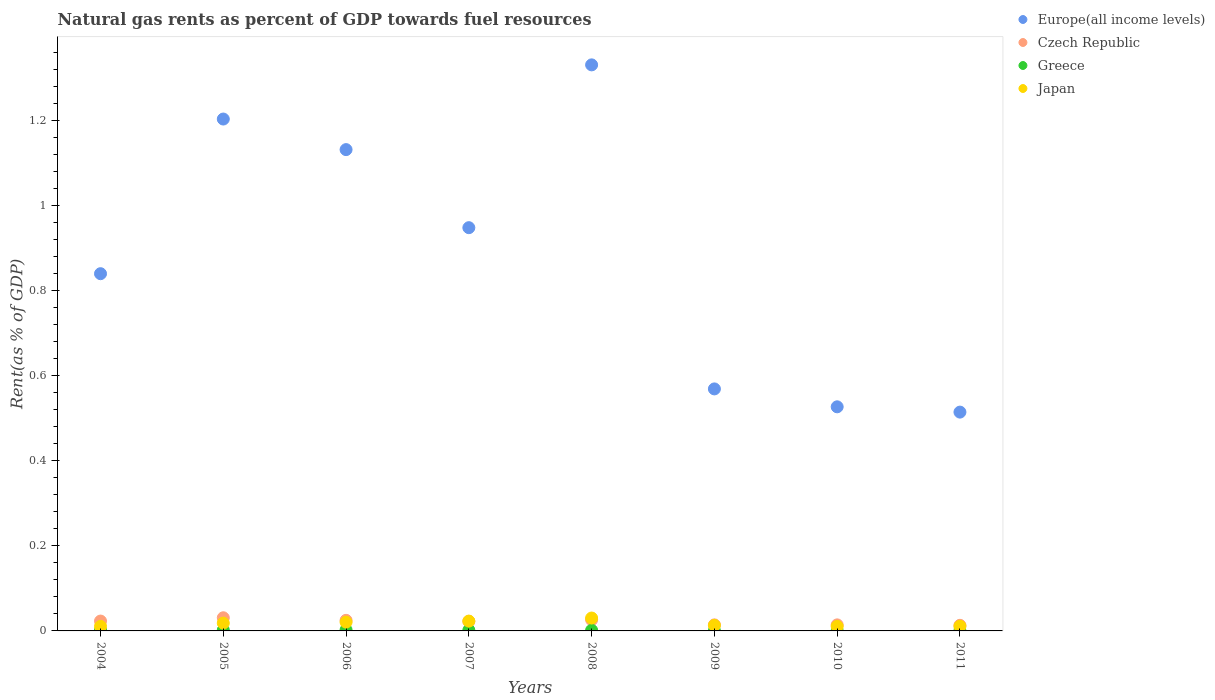Is the number of dotlines equal to the number of legend labels?
Provide a short and direct response. Yes. What is the matural gas rent in Japan in 2011?
Offer a terse response. 0.01. Across all years, what is the maximum matural gas rent in Europe(all income levels)?
Provide a succinct answer. 1.33. Across all years, what is the minimum matural gas rent in Greece?
Your answer should be very brief. 0. In which year was the matural gas rent in Japan minimum?
Your answer should be compact. 2010. What is the total matural gas rent in Greece in the graph?
Provide a short and direct response. 0.01. What is the difference between the matural gas rent in Europe(all income levels) in 2004 and that in 2006?
Your answer should be compact. -0.29. What is the difference between the matural gas rent in Europe(all income levels) in 2006 and the matural gas rent in Japan in 2011?
Ensure brevity in your answer.  1.12. What is the average matural gas rent in Japan per year?
Your answer should be compact. 0.02. In the year 2006, what is the difference between the matural gas rent in Greece and matural gas rent in Europe(all income levels)?
Ensure brevity in your answer.  -1.13. In how many years, is the matural gas rent in Czech Republic greater than 0.28 %?
Offer a very short reply. 0. What is the ratio of the matural gas rent in Greece in 2005 to that in 2009?
Make the answer very short. 3.53. What is the difference between the highest and the second highest matural gas rent in Japan?
Your answer should be compact. 0.01. What is the difference between the highest and the lowest matural gas rent in Japan?
Your answer should be compact. 0.02. In how many years, is the matural gas rent in Europe(all income levels) greater than the average matural gas rent in Europe(all income levels) taken over all years?
Offer a very short reply. 4. Is it the case that in every year, the sum of the matural gas rent in Japan and matural gas rent in Czech Republic  is greater than the sum of matural gas rent in Europe(all income levels) and matural gas rent in Greece?
Give a very brief answer. No. Is it the case that in every year, the sum of the matural gas rent in Europe(all income levels) and matural gas rent in Czech Republic  is greater than the matural gas rent in Japan?
Make the answer very short. Yes. Is the matural gas rent in Czech Republic strictly greater than the matural gas rent in Japan over the years?
Ensure brevity in your answer.  No. How many years are there in the graph?
Offer a terse response. 8. What is the difference between two consecutive major ticks on the Y-axis?
Your answer should be very brief. 0.2. Are the values on the major ticks of Y-axis written in scientific E-notation?
Your answer should be very brief. No. Does the graph contain any zero values?
Your answer should be very brief. No. Does the graph contain grids?
Ensure brevity in your answer.  No. How are the legend labels stacked?
Provide a succinct answer. Vertical. What is the title of the graph?
Ensure brevity in your answer.  Natural gas rents as percent of GDP towards fuel resources. Does "Mozambique" appear as one of the legend labels in the graph?
Offer a very short reply. No. What is the label or title of the Y-axis?
Keep it short and to the point. Rent(as % of GDP). What is the Rent(as % of GDP) of Europe(all income levels) in 2004?
Give a very brief answer. 0.84. What is the Rent(as % of GDP) in Czech Republic in 2004?
Your answer should be very brief. 0.02. What is the Rent(as % of GDP) of Greece in 2004?
Make the answer very short. 0. What is the Rent(as % of GDP) in Japan in 2004?
Keep it short and to the point. 0.01. What is the Rent(as % of GDP) of Europe(all income levels) in 2005?
Offer a terse response. 1.2. What is the Rent(as % of GDP) of Czech Republic in 2005?
Keep it short and to the point. 0.03. What is the Rent(as % of GDP) of Greece in 2005?
Your answer should be compact. 0. What is the Rent(as % of GDP) in Japan in 2005?
Your answer should be compact. 0.02. What is the Rent(as % of GDP) in Europe(all income levels) in 2006?
Make the answer very short. 1.13. What is the Rent(as % of GDP) of Czech Republic in 2006?
Provide a succinct answer. 0.02. What is the Rent(as % of GDP) in Greece in 2006?
Offer a terse response. 0. What is the Rent(as % of GDP) of Japan in 2006?
Provide a short and direct response. 0.02. What is the Rent(as % of GDP) of Europe(all income levels) in 2007?
Ensure brevity in your answer.  0.95. What is the Rent(as % of GDP) of Czech Republic in 2007?
Provide a succinct answer. 0.02. What is the Rent(as % of GDP) in Greece in 2007?
Your answer should be compact. 0. What is the Rent(as % of GDP) in Japan in 2007?
Offer a very short reply. 0.02. What is the Rent(as % of GDP) of Europe(all income levels) in 2008?
Ensure brevity in your answer.  1.33. What is the Rent(as % of GDP) of Czech Republic in 2008?
Make the answer very short. 0.03. What is the Rent(as % of GDP) of Greece in 2008?
Provide a short and direct response. 0. What is the Rent(as % of GDP) in Japan in 2008?
Keep it short and to the point. 0.03. What is the Rent(as % of GDP) in Europe(all income levels) in 2009?
Offer a very short reply. 0.57. What is the Rent(as % of GDP) in Czech Republic in 2009?
Provide a succinct answer. 0.01. What is the Rent(as % of GDP) of Greece in 2009?
Ensure brevity in your answer.  0. What is the Rent(as % of GDP) in Japan in 2009?
Make the answer very short. 0.01. What is the Rent(as % of GDP) of Europe(all income levels) in 2010?
Your answer should be compact. 0.53. What is the Rent(as % of GDP) in Czech Republic in 2010?
Give a very brief answer. 0.01. What is the Rent(as % of GDP) in Greece in 2010?
Provide a short and direct response. 0. What is the Rent(as % of GDP) in Japan in 2010?
Ensure brevity in your answer.  0.01. What is the Rent(as % of GDP) of Europe(all income levels) in 2011?
Your answer should be compact. 0.51. What is the Rent(as % of GDP) of Czech Republic in 2011?
Provide a succinct answer. 0.01. What is the Rent(as % of GDP) in Greece in 2011?
Provide a succinct answer. 0. What is the Rent(as % of GDP) of Japan in 2011?
Make the answer very short. 0.01. Across all years, what is the maximum Rent(as % of GDP) in Europe(all income levels)?
Make the answer very short. 1.33. Across all years, what is the maximum Rent(as % of GDP) in Czech Republic?
Offer a very short reply. 0.03. Across all years, what is the maximum Rent(as % of GDP) of Greece?
Provide a succinct answer. 0. Across all years, what is the maximum Rent(as % of GDP) of Japan?
Provide a short and direct response. 0.03. Across all years, what is the minimum Rent(as % of GDP) in Europe(all income levels)?
Your answer should be very brief. 0.51. Across all years, what is the minimum Rent(as % of GDP) of Czech Republic?
Keep it short and to the point. 0.01. Across all years, what is the minimum Rent(as % of GDP) in Greece?
Your response must be concise. 0. Across all years, what is the minimum Rent(as % of GDP) in Japan?
Provide a succinct answer. 0.01. What is the total Rent(as % of GDP) in Europe(all income levels) in the graph?
Give a very brief answer. 7.06. What is the total Rent(as % of GDP) in Czech Republic in the graph?
Provide a succinct answer. 0.17. What is the total Rent(as % of GDP) of Greece in the graph?
Ensure brevity in your answer.  0.01. What is the total Rent(as % of GDP) in Japan in the graph?
Provide a succinct answer. 0.14. What is the difference between the Rent(as % of GDP) in Europe(all income levels) in 2004 and that in 2005?
Ensure brevity in your answer.  -0.36. What is the difference between the Rent(as % of GDP) in Czech Republic in 2004 and that in 2005?
Offer a terse response. -0.01. What is the difference between the Rent(as % of GDP) in Greece in 2004 and that in 2005?
Your response must be concise. 0. What is the difference between the Rent(as % of GDP) of Japan in 2004 and that in 2005?
Offer a terse response. -0.01. What is the difference between the Rent(as % of GDP) of Europe(all income levels) in 2004 and that in 2006?
Provide a succinct answer. -0.29. What is the difference between the Rent(as % of GDP) of Czech Republic in 2004 and that in 2006?
Offer a terse response. -0. What is the difference between the Rent(as % of GDP) in Greece in 2004 and that in 2006?
Your answer should be very brief. -0. What is the difference between the Rent(as % of GDP) in Japan in 2004 and that in 2006?
Give a very brief answer. -0.01. What is the difference between the Rent(as % of GDP) of Europe(all income levels) in 2004 and that in 2007?
Your answer should be compact. -0.11. What is the difference between the Rent(as % of GDP) of Czech Republic in 2004 and that in 2007?
Give a very brief answer. 0. What is the difference between the Rent(as % of GDP) of Japan in 2004 and that in 2007?
Provide a short and direct response. -0.01. What is the difference between the Rent(as % of GDP) of Europe(all income levels) in 2004 and that in 2008?
Give a very brief answer. -0.49. What is the difference between the Rent(as % of GDP) in Czech Republic in 2004 and that in 2008?
Provide a succinct answer. -0. What is the difference between the Rent(as % of GDP) in Greece in 2004 and that in 2008?
Give a very brief answer. 0. What is the difference between the Rent(as % of GDP) in Japan in 2004 and that in 2008?
Give a very brief answer. -0.02. What is the difference between the Rent(as % of GDP) of Europe(all income levels) in 2004 and that in 2009?
Offer a terse response. 0.27. What is the difference between the Rent(as % of GDP) in Czech Republic in 2004 and that in 2009?
Your response must be concise. 0.01. What is the difference between the Rent(as % of GDP) of Greece in 2004 and that in 2009?
Provide a succinct answer. 0. What is the difference between the Rent(as % of GDP) of Japan in 2004 and that in 2009?
Ensure brevity in your answer.  -0. What is the difference between the Rent(as % of GDP) in Europe(all income levels) in 2004 and that in 2010?
Make the answer very short. 0.31. What is the difference between the Rent(as % of GDP) of Czech Republic in 2004 and that in 2010?
Ensure brevity in your answer.  0.01. What is the difference between the Rent(as % of GDP) in Greece in 2004 and that in 2010?
Offer a terse response. 0. What is the difference between the Rent(as % of GDP) of Japan in 2004 and that in 2010?
Provide a succinct answer. 0. What is the difference between the Rent(as % of GDP) in Europe(all income levels) in 2004 and that in 2011?
Ensure brevity in your answer.  0.33. What is the difference between the Rent(as % of GDP) of Czech Republic in 2004 and that in 2011?
Your response must be concise. 0.01. What is the difference between the Rent(as % of GDP) in Greece in 2004 and that in 2011?
Give a very brief answer. 0. What is the difference between the Rent(as % of GDP) of Japan in 2004 and that in 2011?
Make the answer very short. -0. What is the difference between the Rent(as % of GDP) of Europe(all income levels) in 2005 and that in 2006?
Your response must be concise. 0.07. What is the difference between the Rent(as % of GDP) of Czech Republic in 2005 and that in 2006?
Keep it short and to the point. 0.01. What is the difference between the Rent(as % of GDP) in Greece in 2005 and that in 2006?
Keep it short and to the point. -0. What is the difference between the Rent(as % of GDP) in Japan in 2005 and that in 2006?
Your response must be concise. -0. What is the difference between the Rent(as % of GDP) of Europe(all income levels) in 2005 and that in 2007?
Ensure brevity in your answer.  0.26. What is the difference between the Rent(as % of GDP) of Czech Republic in 2005 and that in 2007?
Ensure brevity in your answer.  0.01. What is the difference between the Rent(as % of GDP) of Greece in 2005 and that in 2007?
Give a very brief answer. 0. What is the difference between the Rent(as % of GDP) in Japan in 2005 and that in 2007?
Keep it short and to the point. -0. What is the difference between the Rent(as % of GDP) in Europe(all income levels) in 2005 and that in 2008?
Keep it short and to the point. -0.13. What is the difference between the Rent(as % of GDP) of Czech Republic in 2005 and that in 2008?
Your response must be concise. 0. What is the difference between the Rent(as % of GDP) of Greece in 2005 and that in 2008?
Give a very brief answer. 0. What is the difference between the Rent(as % of GDP) in Japan in 2005 and that in 2008?
Provide a succinct answer. -0.01. What is the difference between the Rent(as % of GDP) in Europe(all income levels) in 2005 and that in 2009?
Provide a short and direct response. 0.63. What is the difference between the Rent(as % of GDP) in Czech Republic in 2005 and that in 2009?
Offer a terse response. 0.02. What is the difference between the Rent(as % of GDP) of Greece in 2005 and that in 2009?
Give a very brief answer. 0. What is the difference between the Rent(as % of GDP) of Japan in 2005 and that in 2009?
Make the answer very short. 0.01. What is the difference between the Rent(as % of GDP) in Europe(all income levels) in 2005 and that in 2010?
Make the answer very short. 0.68. What is the difference between the Rent(as % of GDP) in Czech Republic in 2005 and that in 2010?
Keep it short and to the point. 0.02. What is the difference between the Rent(as % of GDP) of Greece in 2005 and that in 2010?
Keep it short and to the point. 0. What is the difference between the Rent(as % of GDP) of Japan in 2005 and that in 2010?
Ensure brevity in your answer.  0.01. What is the difference between the Rent(as % of GDP) of Europe(all income levels) in 2005 and that in 2011?
Offer a terse response. 0.69. What is the difference between the Rent(as % of GDP) of Czech Republic in 2005 and that in 2011?
Your answer should be compact. 0.02. What is the difference between the Rent(as % of GDP) in Greece in 2005 and that in 2011?
Your answer should be compact. 0. What is the difference between the Rent(as % of GDP) in Japan in 2005 and that in 2011?
Give a very brief answer. 0.01. What is the difference between the Rent(as % of GDP) in Europe(all income levels) in 2006 and that in 2007?
Your answer should be very brief. 0.18. What is the difference between the Rent(as % of GDP) in Czech Republic in 2006 and that in 2007?
Keep it short and to the point. 0. What is the difference between the Rent(as % of GDP) in Greece in 2006 and that in 2007?
Keep it short and to the point. 0. What is the difference between the Rent(as % of GDP) in Japan in 2006 and that in 2007?
Offer a terse response. -0. What is the difference between the Rent(as % of GDP) of Europe(all income levels) in 2006 and that in 2008?
Keep it short and to the point. -0.2. What is the difference between the Rent(as % of GDP) in Czech Republic in 2006 and that in 2008?
Provide a short and direct response. -0. What is the difference between the Rent(as % of GDP) of Greece in 2006 and that in 2008?
Give a very brief answer. 0. What is the difference between the Rent(as % of GDP) in Japan in 2006 and that in 2008?
Offer a terse response. -0.01. What is the difference between the Rent(as % of GDP) in Europe(all income levels) in 2006 and that in 2009?
Your response must be concise. 0.56. What is the difference between the Rent(as % of GDP) of Czech Republic in 2006 and that in 2009?
Your answer should be very brief. 0.01. What is the difference between the Rent(as % of GDP) in Greece in 2006 and that in 2009?
Offer a terse response. 0. What is the difference between the Rent(as % of GDP) in Japan in 2006 and that in 2009?
Provide a succinct answer. 0.01. What is the difference between the Rent(as % of GDP) of Europe(all income levels) in 2006 and that in 2010?
Offer a terse response. 0.6. What is the difference between the Rent(as % of GDP) of Czech Republic in 2006 and that in 2010?
Offer a very short reply. 0.01. What is the difference between the Rent(as % of GDP) in Greece in 2006 and that in 2010?
Your answer should be compact. 0. What is the difference between the Rent(as % of GDP) of Europe(all income levels) in 2006 and that in 2011?
Make the answer very short. 0.62. What is the difference between the Rent(as % of GDP) in Czech Republic in 2006 and that in 2011?
Your answer should be very brief. 0.01. What is the difference between the Rent(as % of GDP) in Greece in 2006 and that in 2011?
Provide a succinct answer. 0. What is the difference between the Rent(as % of GDP) of Japan in 2006 and that in 2011?
Provide a short and direct response. 0.01. What is the difference between the Rent(as % of GDP) in Europe(all income levels) in 2007 and that in 2008?
Offer a terse response. -0.38. What is the difference between the Rent(as % of GDP) in Czech Republic in 2007 and that in 2008?
Offer a very short reply. -0. What is the difference between the Rent(as % of GDP) in Japan in 2007 and that in 2008?
Your response must be concise. -0.01. What is the difference between the Rent(as % of GDP) in Europe(all income levels) in 2007 and that in 2009?
Offer a terse response. 0.38. What is the difference between the Rent(as % of GDP) in Czech Republic in 2007 and that in 2009?
Keep it short and to the point. 0.01. What is the difference between the Rent(as % of GDP) of Greece in 2007 and that in 2009?
Give a very brief answer. 0. What is the difference between the Rent(as % of GDP) of Europe(all income levels) in 2007 and that in 2010?
Your answer should be very brief. 0.42. What is the difference between the Rent(as % of GDP) of Czech Republic in 2007 and that in 2010?
Your answer should be very brief. 0.01. What is the difference between the Rent(as % of GDP) of Greece in 2007 and that in 2010?
Your answer should be very brief. 0. What is the difference between the Rent(as % of GDP) in Japan in 2007 and that in 2010?
Offer a terse response. 0.01. What is the difference between the Rent(as % of GDP) in Europe(all income levels) in 2007 and that in 2011?
Provide a short and direct response. 0.43. What is the difference between the Rent(as % of GDP) in Czech Republic in 2007 and that in 2011?
Keep it short and to the point. 0.01. What is the difference between the Rent(as % of GDP) of Greece in 2007 and that in 2011?
Ensure brevity in your answer.  0. What is the difference between the Rent(as % of GDP) in Japan in 2007 and that in 2011?
Make the answer very short. 0.01. What is the difference between the Rent(as % of GDP) of Europe(all income levels) in 2008 and that in 2009?
Give a very brief answer. 0.76. What is the difference between the Rent(as % of GDP) of Czech Republic in 2008 and that in 2009?
Give a very brief answer. 0.01. What is the difference between the Rent(as % of GDP) of Greece in 2008 and that in 2009?
Offer a terse response. 0. What is the difference between the Rent(as % of GDP) of Japan in 2008 and that in 2009?
Offer a very short reply. 0.02. What is the difference between the Rent(as % of GDP) in Europe(all income levels) in 2008 and that in 2010?
Your answer should be very brief. 0.8. What is the difference between the Rent(as % of GDP) in Czech Republic in 2008 and that in 2010?
Ensure brevity in your answer.  0.01. What is the difference between the Rent(as % of GDP) in Greece in 2008 and that in 2010?
Make the answer very short. 0. What is the difference between the Rent(as % of GDP) in Japan in 2008 and that in 2010?
Your answer should be very brief. 0.02. What is the difference between the Rent(as % of GDP) of Europe(all income levels) in 2008 and that in 2011?
Keep it short and to the point. 0.82. What is the difference between the Rent(as % of GDP) in Czech Republic in 2008 and that in 2011?
Provide a short and direct response. 0.01. What is the difference between the Rent(as % of GDP) in Greece in 2008 and that in 2011?
Your response must be concise. 0. What is the difference between the Rent(as % of GDP) in Japan in 2008 and that in 2011?
Your answer should be compact. 0.02. What is the difference between the Rent(as % of GDP) of Europe(all income levels) in 2009 and that in 2010?
Your answer should be very brief. 0.04. What is the difference between the Rent(as % of GDP) of Czech Republic in 2009 and that in 2010?
Provide a succinct answer. -0. What is the difference between the Rent(as % of GDP) in Greece in 2009 and that in 2010?
Your answer should be very brief. 0. What is the difference between the Rent(as % of GDP) in Japan in 2009 and that in 2010?
Make the answer very short. 0. What is the difference between the Rent(as % of GDP) of Europe(all income levels) in 2009 and that in 2011?
Give a very brief answer. 0.05. What is the difference between the Rent(as % of GDP) of Czech Republic in 2009 and that in 2011?
Offer a very short reply. 0. What is the difference between the Rent(as % of GDP) in Greece in 2009 and that in 2011?
Make the answer very short. 0. What is the difference between the Rent(as % of GDP) of Japan in 2009 and that in 2011?
Your answer should be compact. 0. What is the difference between the Rent(as % of GDP) of Europe(all income levels) in 2010 and that in 2011?
Give a very brief answer. 0.01. What is the difference between the Rent(as % of GDP) of Greece in 2010 and that in 2011?
Your answer should be compact. 0. What is the difference between the Rent(as % of GDP) in Japan in 2010 and that in 2011?
Your response must be concise. -0. What is the difference between the Rent(as % of GDP) of Europe(all income levels) in 2004 and the Rent(as % of GDP) of Czech Republic in 2005?
Offer a very short reply. 0.81. What is the difference between the Rent(as % of GDP) in Europe(all income levels) in 2004 and the Rent(as % of GDP) in Greece in 2005?
Offer a very short reply. 0.84. What is the difference between the Rent(as % of GDP) in Europe(all income levels) in 2004 and the Rent(as % of GDP) in Japan in 2005?
Your response must be concise. 0.82. What is the difference between the Rent(as % of GDP) of Czech Republic in 2004 and the Rent(as % of GDP) of Greece in 2005?
Make the answer very short. 0.02. What is the difference between the Rent(as % of GDP) in Czech Republic in 2004 and the Rent(as % of GDP) in Japan in 2005?
Your answer should be very brief. 0. What is the difference between the Rent(as % of GDP) of Greece in 2004 and the Rent(as % of GDP) of Japan in 2005?
Ensure brevity in your answer.  -0.02. What is the difference between the Rent(as % of GDP) of Europe(all income levels) in 2004 and the Rent(as % of GDP) of Czech Republic in 2006?
Offer a terse response. 0.81. What is the difference between the Rent(as % of GDP) in Europe(all income levels) in 2004 and the Rent(as % of GDP) in Greece in 2006?
Ensure brevity in your answer.  0.84. What is the difference between the Rent(as % of GDP) in Europe(all income levels) in 2004 and the Rent(as % of GDP) in Japan in 2006?
Give a very brief answer. 0.82. What is the difference between the Rent(as % of GDP) of Czech Republic in 2004 and the Rent(as % of GDP) of Greece in 2006?
Ensure brevity in your answer.  0.02. What is the difference between the Rent(as % of GDP) of Czech Republic in 2004 and the Rent(as % of GDP) of Japan in 2006?
Your answer should be compact. 0. What is the difference between the Rent(as % of GDP) in Greece in 2004 and the Rent(as % of GDP) in Japan in 2006?
Your answer should be very brief. -0.02. What is the difference between the Rent(as % of GDP) of Europe(all income levels) in 2004 and the Rent(as % of GDP) of Czech Republic in 2007?
Give a very brief answer. 0.82. What is the difference between the Rent(as % of GDP) of Europe(all income levels) in 2004 and the Rent(as % of GDP) of Greece in 2007?
Your response must be concise. 0.84. What is the difference between the Rent(as % of GDP) in Europe(all income levels) in 2004 and the Rent(as % of GDP) in Japan in 2007?
Provide a short and direct response. 0.82. What is the difference between the Rent(as % of GDP) in Czech Republic in 2004 and the Rent(as % of GDP) in Greece in 2007?
Keep it short and to the point. 0.02. What is the difference between the Rent(as % of GDP) of Greece in 2004 and the Rent(as % of GDP) of Japan in 2007?
Provide a succinct answer. -0.02. What is the difference between the Rent(as % of GDP) of Europe(all income levels) in 2004 and the Rent(as % of GDP) of Czech Republic in 2008?
Provide a succinct answer. 0.81. What is the difference between the Rent(as % of GDP) in Europe(all income levels) in 2004 and the Rent(as % of GDP) in Greece in 2008?
Offer a terse response. 0.84. What is the difference between the Rent(as % of GDP) of Europe(all income levels) in 2004 and the Rent(as % of GDP) of Japan in 2008?
Offer a terse response. 0.81. What is the difference between the Rent(as % of GDP) of Czech Republic in 2004 and the Rent(as % of GDP) of Greece in 2008?
Ensure brevity in your answer.  0.02. What is the difference between the Rent(as % of GDP) in Czech Republic in 2004 and the Rent(as % of GDP) in Japan in 2008?
Your response must be concise. -0.01. What is the difference between the Rent(as % of GDP) of Greece in 2004 and the Rent(as % of GDP) of Japan in 2008?
Keep it short and to the point. -0.03. What is the difference between the Rent(as % of GDP) of Europe(all income levels) in 2004 and the Rent(as % of GDP) of Czech Republic in 2009?
Your answer should be very brief. 0.83. What is the difference between the Rent(as % of GDP) in Europe(all income levels) in 2004 and the Rent(as % of GDP) in Greece in 2009?
Offer a terse response. 0.84. What is the difference between the Rent(as % of GDP) in Europe(all income levels) in 2004 and the Rent(as % of GDP) in Japan in 2009?
Ensure brevity in your answer.  0.83. What is the difference between the Rent(as % of GDP) of Czech Republic in 2004 and the Rent(as % of GDP) of Greece in 2009?
Your answer should be compact. 0.02. What is the difference between the Rent(as % of GDP) of Czech Republic in 2004 and the Rent(as % of GDP) of Japan in 2009?
Offer a terse response. 0.01. What is the difference between the Rent(as % of GDP) of Greece in 2004 and the Rent(as % of GDP) of Japan in 2009?
Keep it short and to the point. -0.01. What is the difference between the Rent(as % of GDP) of Europe(all income levels) in 2004 and the Rent(as % of GDP) of Czech Republic in 2010?
Ensure brevity in your answer.  0.83. What is the difference between the Rent(as % of GDP) in Europe(all income levels) in 2004 and the Rent(as % of GDP) in Greece in 2010?
Offer a very short reply. 0.84. What is the difference between the Rent(as % of GDP) in Europe(all income levels) in 2004 and the Rent(as % of GDP) in Japan in 2010?
Give a very brief answer. 0.83. What is the difference between the Rent(as % of GDP) of Czech Republic in 2004 and the Rent(as % of GDP) of Greece in 2010?
Make the answer very short. 0.02. What is the difference between the Rent(as % of GDP) in Czech Republic in 2004 and the Rent(as % of GDP) in Japan in 2010?
Provide a succinct answer. 0.01. What is the difference between the Rent(as % of GDP) of Greece in 2004 and the Rent(as % of GDP) of Japan in 2010?
Your response must be concise. -0.01. What is the difference between the Rent(as % of GDP) of Europe(all income levels) in 2004 and the Rent(as % of GDP) of Czech Republic in 2011?
Ensure brevity in your answer.  0.83. What is the difference between the Rent(as % of GDP) in Europe(all income levels) in 2004 and the Rent(as % of GDP) in Greece in 2011?
Provide a succinct answer. 0.84. What is the difference between the Rent(as % of GDP) in Europe(all income levels) in 2004 and the Rent(as % of GDP) in Japan in 2011?
Keep it short and to the point. 0.83. What is the difference between the Rent(as % of GDP) of Czech Republic in 2004 and the Rent(as % of GDP) of Greece in 2011?
Offer a terse response. 0.02. What is the difference between the Rent(as % of GDP) in Czech Republic in 2004 and the Rent(as % of GDP) in Japan in 2011?
Offer a very short reply. 0.01. What is the difference between the Rent(as % of GDP) in Greece in 2004 and the Rent(as % of GDP) in Japan in 2011?
Provide a short and direct response. -0.01. What is the difference between the Rent(as % of GDP) in Europe(all income levels) in 2005 and the Rent(as % of GDP) in Czech Republic in 2006?
Give a very brief answer. 1.18. What is the difference between the Rent(as % of GDP) of Europe(all income levels) in 2005 and the Rent(as % of GDP) of Greece in 2006?
Offer a terse response. 1.2. What is the difference between the Rent(as % of GDP) in Europe(all income levels) in 2005 and the Rent(as % of GDP) in Japan in 2006?
Provide a short and direct response. 1.18. What is the difference between the Rent(as % of GDP) of Czech Republic in 2005 and the Rent(as % of GDP) of Greece in 2006?
Make the answer very short. 0.03. What is the difference between the Rent(as % of GDP) in Czech Republic in 2005 and the Rent(as % of GDP) in Japan in 2006?
Your answer should be very brief. 0.01. What is the difference between the Rent(as % of GDP) of Greece in 2005 and the Rent(as % of GDP) of Japan in 2006?
Provide a short and direct response. -0.02. What is the difference between the Rent(as % of GDP) of Europe(all income levels) in 2005 and the Rent(as % of GDP) of Czech Republic in 2007?
Provide a short and direct response. 1.18. What is the difference between the Rent(as % of GDP) in Europe(all income levels) in 2005 and the Rent(as % of GDP) in Greece in 2007?
Your answer should be compact. 1.2. What is the difference between the Rent(as % of GDP) of Europe(all income levels) in 2005 and the Rent(as % of GDP) of Japan in 2007?
Your answer should be very brief. 1.18. What is the difference between the Rent(as % of GDP) in Czech Republic in 2005 and the Rent(as % of GDP) in Greece in 2007?
Your response must be concise. 0.03. What is the difference between the Rent(as % of GDP) of Czech Republic in 2005 and the Rent(as % of GDP) of Japan in 2007?
Give a very brief answer. 0.01. What is the difference between the Rent(as % of GDP) of Greece in 2005 and the Rent(as % of GDP) of Japan in 2007?
Your answer should be compact. -0.02. What is the difference between the Rent(as % of GDP) in Europe(all income levels) in 2005 and the Rent(as % of GDP) in Czech Republic in 2008?
Ensure brevity in your answer.  1.18. What is the difference between the Rent(as % of GDP) of Europe(all income levels) in 2005 and the Rent(as % of GDP) of Greece in 2008?
Offer a very short reply. 1.2. What is the difference between the Rent(as % of GDP) of Europe(all income levels) in 2005 and the Rent(as % of GDP) of Japan in 2008?
Keep it short and to the point. 1.17. What is the difference between the Rent(as % of GDP) of Czech Republic in 2005 and the Rent(as % of GDP) of Greece in 2008?
Offer a very short reply. 0.03. What is the difference between the Rent(as % of GDP) of Czech Republic in 2005 and the Rent(as % of GDP) of Japan in 2008?
Ensure brevity in your answer.  0. What is the difference between the Rent(as % of GDP) in Greece in 2005 and the Rent(as % of GDP) in Japan in 2008?
Make the answer very short. -0.03. What is the difference between the Rent(as % of GDP) of Europe(all income levels) in 2005 and the Rent(as % of GDP) of Czech Republic in 2009?
Provide a succinct answer. 1.19. What is the difference between the Rent(as % of GDP) in Europe(all income levels) in 2005 and the Rent(as % of GDP) in Greece in 2009?
Your answer should be compact. 1.2. What is the difference between the Rent(as % of GDP) in Europe(all income levels) in 2005 and the Rent(as % of GDP) in Japan in 2009?
Keep it short and to the point. 1.19. What is the difference between the Rent(as % of GDP) in Czech Republic in 2005 and the Rent(as % of GDP) in Greece in 2009?
Make the answer very short. 0.03. What is the difference between the Rent(as % of GDP) in Czech Republic in 2005 and the Rent(as % of GDP) in Japan in 2009?
Give a very brief answer. 0.02. What is the difference between the Rent(as % of GDP) of Greece in 2005 and the Rent(as % of GDP) of Japan in 2009?
Keep it short and to the point. -0.01. What is the difference between the Rent(as % of GDP) in Europe(all income levels) in 2005 and the Rent(as % of GDP) in Czech Republic in 2010?
Keep it short and to the point. 1.19. What is the difference between the Rent(as % of GDP) in Europe(all income levels) in 2005 and the Rent(as % of GDP) in Greece in 2010?
Keep it short and to the point. 1.2. What is the difference between the Rent(as % of GDP) in Europe(all income levels) in 2005 and the Rent(as % of GDP) in Japan in 2010?
Ensure brevity in your answer.  1.19. What is the difference between the Rent(as % of GDP) in Czech Republic in 2005 and the Rent(as % of GDP) in Greece in 2010?
Offer a terse response. 0.03. What is the difference between the Rent(as % of GDP) of Czech Republic in 2005 and the Rent(as % of GDP) of Japan in 2010?
Provide a succinct answer. 0.02. What is the difference between the Rent(as % of GDP) in Greece in 2005 and the Rent(as % of GDP) in Japan in 2010?
Ensure brevity in your answer.  -0.01. What is the difference between the Rent(as % of GDP) in Europe(all income levels) in 2005 and the Rent(as % of GDP) in Czech Republic in 2011?
Provide a succinct answer. 1.19. What is the difference between the Rent(as % of GDP) of Europe(all income levels) in 2005 and the Rent(as % of GDP) of Greece in 2011?
Make the answer very short. 1.2. What is the difference between the Rent(as % of GDP) in Europe(all income levels) in 2005 and the Rent(as % of GDP) in Japan in 2011?
Offer a very short reply. 1.19. What is the difference between the Rent(as % of GDP) of Czech Republic in 2005 and the Rent(as % of GDP) of Greece in 2011?
Your answer should be very brief. 0.03. What is the difference between the Rent(as % of GDP) in Greece in 2005 and the Rent(as % of GDP) in Japan in 2011?
Give a very brief answer. -0.01. What is the difference between the Rent(as % of GDP) in Europe(all income levels) in 2006 and the Rent(as % of GDP) in Czech Republic in 2007?
Offer a terse response. 1.11. What is the difference between the Rent(as % of GDP) of Europe(all income levels) in 2006 and the Rent(as % of GDP) of Greece in 2007?
Provide a succinct answer. 1.13. What is the difference between the Rent(as % of GDP) of Europe(all income levels) in 2006 and the Rent(as % of GDP) of Japan in 2007?
Keep it short and to the point. 1.11. What is the difference between the Rent(as % of GDP) in Czech Republic in 2006 and the Rent(as % of GDP) in Greece in 2007?
Provide a succinct answer. 0.02. What is the difference between the Rent(as % of GDP) of Czech Republic in 2006 and the Rent(as % of GDP) of Japan in 2007?
Provide a short and direct response. 0. What is the difference between the Rent(as % of GDP) of Greece in 2006 and the Rent(as % of GDP) of Japan in 2007?
Provide a short and direct response. -0.02. What is the difference between the Rent(as % of GDP) in Europe(all income levels) in 2006 and the Rent(as % of GDP) in Czech Republic in 2008?
Your answer should be very brief. 1.11. What is the difference between the Rent(as % of GDP) of Europe(all income levels) in 2006 and the Rent(as % of GDP) of Greece in 2008?
Ensure brevity in your answer.  1.13. What is the difference between the Rent(as % of GDP) of Europe(all income levels) in 2006 and the Rent(as % of GDP) of Japan in 2008?
Your response must be concise. 1.1. What is the difference between the Rent(as % of GDP) in Czech Republic in 2006 and the Rent(as % of GDP) in Greece in 2008?
Make the answer very short. 0.02. What is the difference between the Rent(as % of GDP) in Czech Republic in 2006 and the Rent(as % of GDP) in Japan in 2008?
Your response must be concise. -0.01. What is the difference between the Rent(as % of GDP) of Greece in 2006 and the Rent(as % of GDP) of Japan in 2008?
Your response must be concise. -0.03. What is the difference between the Rent(as % of GDP) in Europe(all income levels) in 2006 and the Rent(as % of GDP) in Czech Republic in 2009?
Provide a succinct answer. 1.12. What is the difference between the Rent(as % of GDP) in Europe(all income levels) in 2006 and the Rent(as % of GDP) in Greece in 2009?
Your answer should be compact. 1.13. What is the difference between the Rent(as % of GDP) in Europe(all income levels) in 2006 and the Rent(as % of GDP) in Japan in 2009?
Keep it short and to the point. 1.12. What is the difference between the Rent(as % of GDP) in Czech Republic in 2006 and the Rent(as % of GDP) in Greece in 2009?
Your answer should be very brief. 0.02. What is the difference between the Rent(as % of GDP) of Czech Republic in 2006 and the Rent(as % of GDP) of Japan in 2009?
Your response must be concise. 0.01. What is the difference between the Rent(as % of GDP) in Greece in 2006 and the Rent(as % of GDP) in Japan in 2009?
Ensure brevity in your answer.  -0.01. What is the difference between the Rent(as % of GDP) of Europe(all income levels) in 2006 and the Rent(as % of GDP) of Czech Republic in 2010?
Offer a terse response. 1.12. What is the difference between the Rent(as % of GDP) in Europe(all income levels) in 2006 and the Rent(as % of GDP) in Greece in 2010?
Keep it short and to the point. 1.13. What is the difference between the Rent(as % of GDP) in Europe(all income levels) in 2006 and the Rent(as % of GDP) in Japan in 2010?
Give a very brief answer. 1.12. What is the difference between the Rent(as % of GDP) in Czech Republic in 2006 and the Rent(as % of GDP) in Greece in 2010?
Your answer should be very brief. 0.02. What is the difference between the Rent(as % of GDP) in Czech Republic in 2006 and the Rent(as % of GDP) in Japan in 2010?
Provide a succinct answer. 0.01. What is the difference between the Rent(as % of GDP) in Greece in 2006 and the Rent(as % of GDP) in Japan in 2010?
Offer a very short reply. -0.01. What is the difference between the Rent(as % of GDP) in Europe(all income levels) in 2006 and the Rent(as % of GDP) in Czech Republic in 2011?
Offer a terse response. 1.12. What is the difference between the Rent(as % of GDP) of Europe(all income levels) in 2006 and the Rent(as % of GDP) of Greece in 2011?
Provide a short and direct response. 1.13. What is the difference between the Rent(as % of GDP) in Europe(all income levels) in 2006 and the Rent(as % of GDP) in Japan in 2011?
Offer a terse response. 1.12. What is the difference between the Rent(as % of GDP) of Czech Republic in 2006 and the Rent(as % of GDP) of Greece in 2011?
Your response must be concise. 0.02. What is the difference between the Rent(as % of GDP) in Czech Republic in 2006 and the Rent(as % of GDP) in Japan in 2011?
Your answer should be very brief. 0.01. What is the difference between the Rent(as % of GDP) of Greece in 2006 and the Rent(as % of GDP) of Japan in 2011?
Provide a short and direct response. -0.01. What is the difference between the Rent(as % of GDP) of Europe(all income levels) in 2007 and the Rent(as % of GDP) of Czech Republic in 2008?
Provide a short and direct response. 0.92. What is the difference between the Rent(as % of GDP) in Europe(all income levels) in 2007 and the Rent(as % of GDP) in Greece in 2008?
Your answer should be very brief. 0.95. What is the difference between the Rent(as % of GDP) of Europe(all income levels) in 2007 and the Rent(as % of GDP) of Japan in 2008?
Offer a very short reply. 0.92. What is the difference between the Rent(as % of GDP) in Czech Republic in 2007 and the Rent(as % of GDP) in Greece in 2008?
Make the answer very short. 0.02. What is the difference between the Rent(as % of GDP) of Czech Republic in 2007 and the Rent(as % of GDP) of Japan in 2008?
Your response must be concise. -0.01. What is the difference between the Rent(as % of GDP) in Greece in 2007 and the Rent(as % of GDP) in Japan in 2008?
Offer a very short reply. -0.03. What is the difference between the Rent(as % of GDP) of Europe(all income levels) in 2007 and the Rent(as % of GDP) of Czech Republic in 2009?
Provide a succinct answer. 0.93. What is the difference between the Rent(as % of GDP) of Europe(all income levels) in 2007 and the Rent(as % of GDP) of Greece in 2009?
Ensure brevity in your answer.  0.95. What is the difference between the Rent(as % of GDP) of Europe(all income levels) in 2007 and the Rent(as % of GDP) of Japan in 2009?
Your answer should be compact. 0.93. What is the difference between the Rent(as % of GDP) of Czech Republic in 2007 and the Rent(as % of GDP) of Greece in 2009?
Ensure brevity in your answer.  0.02. What is the difference between the Rent(as % of GDP) in Czech Republic in 2007 and the Rent(as % of GDP) in Japan in 2009?
Make the answer very short. 0.01. What is the difference between the Rent(as % of GDP) in Greece in 2007 and the Rent(as % of GDP) in Japan in 2009?
Offer a terse response. -0.01. What is the difference between the Rent(as % of GDP) in Europe(all income levels) in 2007 and the Rent(as % of GDP) in Czech Republic in 2010?
Your response must be concise. 0.93. What is the difference between the Rent(as % of GDP) of Europe(all income levels) in 2007 and the Rent(as % of GDP) of Japan in 2010?
Your answer should be compact. 0.94. What is the difference between the Rent(as % of GDP) of Czech Republic in 2007 and the Rent(as % of GDP) of Greece in 2010?
Make the answer very short. 0.02. What is the difference between the Rent(as % of GDP) of Czech Republic in 2007 and the Rent(as % of GDP) of Japan in 2010?
Provide a short and direct response. 0.01. What is the difference between the Rent(as % of GDP) of Greece in 2007 and the Rent(as % of GDP) of Japan in 2010?
Ensure brevity in your answer.  -0.01. What is the difference between the Rent(as % of GDP) of Europe(all income levels) in 2007 and the Rent(as % of GDP) of Czech Republic in 2011?
Offer a terse response. 0.93. What is the difference between the Rent(as % of GDP) of Europe(all income levels) in 2007 and the Rent(as % of GDP) of Greece in 2011?
Provide a succinct answer. 0.95. What is the difference between the Rent(as % of GDP) of Europe(all income levels) in 2007 and the Rent(as % of GDP) of Japan in 2011?
Provide a short and direct response. 0.94. What is the difference between the Rent(as % of GDP) in Czech Republic in 2007 and the Rent(as % of GDP) in Greece in 2011?
Your answer should be very brief. 0.02. What is the difference between the Rent(as % of GDP) in Czech Republic in 2007 and the Rent(as % of GDP) in Japan in 2011?
Your response must be concise. 0.01. What is the difference between the Rent(as % of GDP) of Greece in 2007 and the Rent(as % of GDP) of Japan in 2011?
Your answer should be compact. -0.01. What is the difference between the Rent(as % of GDP) in Europe(all income levels) in 2008 and the Rent(as % of GDP) in Czech Republic in 2009?
Offer a very short reply. 1.32. What is the difference between the Rent(as % of GDP) in Europe(all income levels) in 2008 and the Rent(as % of GDP) in Greece in 2009?
Your response must be concise. 1.33. What is the difference between the Rent(as % of GDP) in Europe(all income levels) in 2008 and the Rent(as % of GDP) in Japan in 2009?
Give a very brief answer. 1.32. What is the difference between the Rent(as % of GDP) of Czech Republic in 2008 and the Rent(as % of GDP) of Greece in 2009?
Provide a short and direct response. 0.03. What is the difference between the Rent(as % of GDP) of Czech Republic in 2008 and the Rent(as % of GDP) of Japan in 2009?
Provide a succinct answer. 0.01. What is the difference between the Rent(as % of GDP) in Greece in 2008 and the Rent(as % of GDP) in Japan in 2009?
Offer a very short reply. -0.01. What is the difference between the Rent(as % of GDP) of Europe(all income levels) in 2008 and the Rent(as % of GDP) of Czech Republic in 2010?
Give a very brief answer. 1.32. What is the difference between the Rent(as % of GDP) in Europe(all income levels) in 2008 and the Rent(as % of GDP) in Greece in 2010?
Keep it short and to the point. 1.33. What is the difference between the Rent(as % of GDP) of Europe(all income levels) in 2008 and the Rent(as % of GDP) of Japan in 2010?
Provide a short and direct response. 1.32. What is the difference between the Rent(as % of GDP) of Czech Republic in 2008 and the Rent(as % of GDP) of Greece in 2010?
Provide a short and direct response. 0.03. What is the difference between the Rent(as % of GDP) in Czech Republic in 2008 and the Rent(as % of GDP) in Japan in 2010?
Ensure brevity in your answer.  0.02. What is the difference between the Rent(as % of GDP) in Greece in 2008 and the Rent(as % of GDP) in Japan in 2010?
Your answer should be very brief. -0.01. What is the difference between the Rent(as % of GDP) of Europe(all income levels) in 2008 and the Rent(as % of GDP) of Czech Republic in 2011?
Ensure brevity in your answer.  1.32. What is the difference between the Rent(as % of GDP) in Europe(all income levels) in 2008 and the Rent(as % of GDP) in Greece in 2011?
Your answer should be compact. 1.33. What is the difference between the Rent(as % of GDP) of Europe(all income levels) in 2008 and the Rent(as % of GDP) of Japan in 2011?
Your response must be concise. 1.32. What is the difference between the Rent(as % of GDP) of Czech Republic in 2008 and the Rent(as % of GDP) of Greece in 2011?
Give a very brief answer. 0.03. What is the difference between the Rent(as % of GDP) in Czech Republic in 2008 and the Rent(as % of GDP) in Japan in 2011?
Your answer should be very brief. 0.02. What is the difference between the Rent(as % of GDP) of Greece in 2008 and the Rent(as % of GDP) of Japan in 2011?
Keep it short and to the point. -0.01. What is the difference between the Rent(as % of GDP) of Europe(all income levels) in 2009 and the Rent(as % of GDP) of Czech Republic in 2010?
Provide a succinct answer. 0.55. What is the difference between the Rent(as % of GDP) in Europe(all income levels) in 2009 and the Rent(as % of GDP) in Greece in 2010?
Provide a short and direct response. 0.57. What is the difference between the Rent(as % of GDP) in Europe(all income levels) in 2009 and the Rent(as % of GDP) in Japan in 2010?
Offer a terse response. 0.56. What is the difference between the Rent(as % of GDP) in Czech Republic in 2009 and the Rent(as % of GDP) in Greece in 2010?
Offer a terse response. 0.01. What is the difference between the Rent(as % of GDP) of Czech Republic in 2009 and the Rent(as % of GDP) of Japan in 2010?
Make the answer very short. 0. What is the difference between the Rent(as % of GDP) of Greece in 2009 and the Rent(as % of GDP) of Japan in 2010?
Keep it short and to the point. -0.01. What is the difference between the Rent(as % of GDP) of Europe(all income levels) in 2009 and the Rent(as % of GDP) of Czech Republic in 2011?
Offer a terse response. 0.56. What is the difference between the Rent(as % of GDP) in Europe(all income levels) in 2009 and the Rent(as % of GDP) in Greece in 2011?
Offer a very short reply. 0.57. What is the difference between the Rent(as % of GDP) in Europe(all income levels) in 2009 and the Rent(as % of GDP) in Japan in 2011?
Keep it short and to the point. 0.56. What is the difference between the Rent(as % of GDP) of Czech Republic in 2009 and the Rent(as % of GDP) of Greece in 2011?
Provide a succinct answer. 0.01. What is the difference between the Rent(as % of GDP) in Czech Republic in 2009 and the Rent(as % of GDP) in Japan in 2011?
Your response must be concise. 0. What is the difference between the Rent(as % of GDP) of Greece in 2009 and the Rent(as % of GDP) of Japan in 2011?
Your answer should be compact. -0.01. What is the difference between the Rent(as % of GDP) of Europe(all income levels) in 2010 and the Rent(as % of GDP) of Czech Republic in 2011?
Offer a terse response. 0.51. What is the difference between the Rent(as % of GDP) of Europe(all income levels) in 2010 and the Rent(as % of GDP) of Greece in 2011?
Provide a short and direct response. 0.53. What is the difference between the Rent(as % of GDP) in Europe(all income levels) in 2010 and the Rent(as % of GDP) in Japan in 2011?
Provide a succinct answer. 0.52. What is the difference between the Rent(as % of GDP) of Czech Republic in 2010 and the Rent(as % of GDP) of Greece in 2011?
Provide a short and direct response. 0.01. What is the difference between the Rent(as % of GDP) of Czech Republic in 2010 and the Rent(as % of GDP) of Japan in 2011?
Your response must be concise. 0. What is the difference between the Rent(as % of GDP) in Greece in 2010 and the Rent(as % of GDP) in Japan in 2011?
Your answer should be very brief. -0.01. What is the average Rent(as % of GDP) in Europe(all income levels) per year?
Ensure brevity in your answer.  0.88. What is the average Rent(as % of GDP) in Czech Republic per year?
Your answer should be very brief. 0.02. What is the average Rent(as % of GDP) of Greece per year?
Your response must be concise. 0. What is the average Rent(as % of GDP) of Japan per year?
Offer a terse response. 0.02. In the year 2004, what is the difference between the Rent(as % of GDP) of Europe(all income levels) and Rent(as % of GDP) of Czech Republic?
Your answer should be very brief. 0.82. In the year 2004, what is the difference between the Rent(as % of GDP) in Europe(all income levels) and Rent(as % of GDP) in Greece?
Make the answer very short. 0.84. In the year 2004, what is the difference between the Rent(as % of GDP) in Europe(all income levels) and Rent(as % of GDP) in Japan?
Ensure brevity in your answer.  0.83. In the year 2004, what is the difference between the Rent(as % of GDP) in Czech Republic and Rent(as % of GDP) in Greece?
Your answer should be very brief. 0.02. In the year 2004, what is the difference between the Rent(as % of GDP) in Czech Republic and Rent(as % of GDP) in Japan?
Give a very brief answer. 0.01. In the year 2004, what is the difference between the Rent(as % of GDP) of Greece and Rent(as % of GDP) of Japan?
Provide a short and direct response. -0.01. In the year 2005, what is the difference between the Rent(as % of GDP) in Europe(all income levels) and Rent(as % of GDP) in Czech Republic?
Your answer should be compact. 1.17. In the year 2005, what is the difference between the Rent(as % of GDP) of Europe(all income levels) and Rent(as % of GDP) of Greece?
Keep it short and to the point. 1.2. In the year 2005, what is the difference between the Rent(as % of GDP) of Europe(all income levels) and Rent(as % of GDP) of Japan?
Offer a terse response. 1.18. In the year 2005, what is the difference between the Rent(as % of GDP) in Czech Republic and Rent(as % of GDP) in Greece?
Your response must be concise. 0.03. In the year 2005, what is the difference between the Rent(as % of GDP) of Czech Republic and Rent(as % of GDP) of Japan?
Provide a succinct answer. 0.01. In the year 2005, what is the difference between the Rent(as % of GDP) in Greece and Rent(as % of GDP) in Japan?
Your answer should be very brief. -0.02. In the year 2006, what is the difference between the Rent(as % of GDP) in Europe(all income levels) and Rent(as % of GDP) in Czech Republic?
Keep it short and to the point. 1.11. In the year 2006, what is the difference between the Rent(as % of GDP) of Europe(all income levels) and Rent(as % of GDP) of Greece?
Ensure brevity in your answer.  1.13. In the year 2006, what is the difference between the Rent(as % of GDP) of Europe(all income levels) and Rent(as % of GDP) of Japan?
Provide a succinct answer. 1.11. In the year 2006, what is the difference between the Rent(as % of GDP) of Czech Republic and Rent(as % of GDP) of Greece?
Make the answer very short. 0.02. In the year 2006, what is the difference between the Rent(as % of GDP) of Czech Republic and Rent(as % of GDP) of Japan?
Provide a succinct answer. 0. In the year 2006, what is the difference between the Rent(as % of GDP) of Greece and Rent(as % of GDP) of Japan?
Your answer should be very brief. -0.02. In the year 2007, what is the difference between the Rent(as % of GDP) of Europe(all income levels) and Rent(as % of GDP) of Czech Republic?
Your answer should be very brief. 0.93. In the year 2007, what is the difference between the Rent(as % of GDP) in Europe(all income levels) and Rent(as % of GDP) in Greece?
Your response must be concise. 0.95. In the year 2007, what is the difference between the Rent(as % of GDP) of Europe(all income levels) and Rent(as % of GDP) of Japan?
Your response must be concise. 0.92. In the year 2007, what is the difference between the Rent(as % of GDP) of Czech Republic and Rent(as % of GDP) of Greece?
Give a very brief answer. 0.02. In the year 2007, what is the difference between the Rent(as % of GDP) of Czech Republic and Rent(as % of GDP) of Japan?
Offer a very short reply. -0. In the year 2007, what is the difference between the Rent(as % of GDP) in Greece and Rent(as % of GDP) in Japan?
Offer a terse response. -0.02. In the year 2008, what is the difference between the Rent(as % of GDP) in Europe(all income levels) and Rent(as % of GDP) in Czech Republic?
Keep it short and to the point. 1.3. In the year 2008, what is the difference between the Rent(as % of GDP) of Europe(all income levels) and Rent(as % of GDP) of Greece?
Your answer should be very brief. 1.33. In the year 2008, what is the difference between the Rent(as % of GDP) in Europe(all income levels) and Rent(as % of GDP) in Japan?
Offer a terse response. 1.3. In the year 2008, what is the difference between the Rent(as % of GDP) in Czech Republic and Rent(as % of GDP) in Greece?
Your answer should be compact. 0.02. In the year 2008, what is the difference between the Rent(as % of GDP) in Czech Republic and Rent(as % of GDP) in Japan?
Offer a terse response. -0. In the year 2008, what is the difference between the Rent(as % of GDP) in Greece and Rent(as % of GDP) in Japan?
Provide a short and direct response. -0.03. In the year 2009, what is the difference between the Rent(as % of GDP) of Europe(all income levels) and Rent(as % of GDP) of Czech Republic?
Offer a very short reply. 0.55. In the year 2009, what is the difference between the Rent(as % of GDP) in Europe(all income levels) and Rent(as % of GDP) in Greece?
Your response must be concise. 0.57. In the year 2009, what is the difference between the Rent(as % of GDP) in Europe(all income levels) and Rent(as % of GDP) in Japan?
Ensure brevity in your answer.  0.56. In the year 2009, what is the difference between the Rent(as % of GDP) of Czech Republic and Rent(as % of GDP) of Greece?
Keep it short and to the point. 0.01. In the year 2009, what is the difference between the Rent(as % of GDP) in Czech Republic and Rent(as % of GDP) in Japan?
Offer a very short reply. 0. In the year 2009, what is the difference between the Rent(as % of GDP) in Greece and Rent(as % of GDP) in Japan?
Provide a succinct answer. -0.01. In the year 2010, what is the difference between the Rent(as % of GDP) in Europe(all income levels) and Rent(as % of GDP) in Czech Republic?
Your answer should be very brief. 0.51. In the year 2010, what is the difference between the Rent(as % of GDP) in Europe(all income levels) and Rent(as % of GDP) in Greece?
Offer a terse response. 0.53. In the year 2010, what is the difference between the Rent(as % of GDP) in Europe(all income levels) and Rent(as % of GDP) in Japan?
Your answer should be very brief. 0.52. In the year 2010, what is the difference between the Rent(as % of GDP) in Czech Republic and Rent(as % of GDP) in Greece?
Your answer should be very brief. 0.01. In the year 2010, what is the difference between the Rent(as % of GDP) of Czech Republic and Rent(as % of GDP) of Japan?
Your answer should be very brief. 0. In the year 2010, what is the difference between the Rent(as % of GDP) in Greece and Rent(as % of GDP) in Japan?
Provide a succinct answer. -0.01. In the year 2011, what is the difference between the Rent(as % of GDP) of Europe(all income levels) and Rent(as % of GDP) of Czech Republic?
Give a very brief answer. 0.5. In the year 2011, what is the difference between the Rent(as % of GDP) of Europe(all income levels) and Rent(as % of GDP) of Greece?
Keep it short and to the point. 0.51. In the year 2011, what is the difference between the Rent(as % of GDP) of Europe(all income levels) and Rent(as % of GDP) of Japan?
Provide a short and direct response. 0.5. In the year 2011, what is the difference between the Rent(as % of GDP) in Czech Republic and Rent(as % of GDP) in Greece?
Your answer should be very brief. 0.01. In the year 2011, what is the difference between the Rent(as % of GDP) of Czech Republic and Rent(as % of GDP) of Japan?
Provide a succinct answer. 0. In the year 2011, what is the difference between the Rent(as % of GDP) in Greece and Rent(as % of GDP) in Japan?
Make the answer very short. -0.01. What is the ratio of the Rent(as % of GDP) in Europe(all income levels) in 2004 to that in 2005?
Provide a short and direct response. 0.7. What is the ratio of the Rent(as % of GDP) in Czech Republic in 2004 to that in 2005?
Offer a terse response. 0.75. What is the ratio of the Rent(as % of GDP) of Greece in 2004 to that in 2005?
Keep it short and to the point. 1.01. What is the ratio of the Rent(as % of GDP) of Japan in 2004 to that in 2005?
Your answer should be compact. 0.58. What is the ratio of the Rent(as % of GDP) of Europe(all income levels) in 2004 to that in 2006?
Your answer should be very brief. 0.74. What is the ratio of the Rent(as % of GDP) in Czech Republic in 2004 to that in 2006?
Your answer should be very brief. 0.93. What is the ratio of the Rent(as % of GDP) in Greece in 2004 to that in 2006?
Make the answer very short. 0.82. What is the ratio of the Rent(as % of GDP) of Japan in 2004 to that in 2006?
Your answer should be very brief. 0.52. What is the ratio of the Rent(as % of GDP) in Europe(all income levels) in 2004 to that in 2007?
Offer a terse response. 0.89. What is the ratio of the Rent(as % of GDP) of Czech Republic in 2004 to that in 2007?
Your answer should be very brief. 1.03. What is the ratio of the Rent(as % of GDP) of Greece in 2004 to that in 2007?
Keep it short and to the point. 1.14. What is the ratio of the Rent(as % of GDP) in Japan in 2004 to that in 2007?
Ensure brevity in your answer.  0.46. What is the ratio of the Rent(as % of GDP) of Europe(all income levels) in 2004 to that in 2008?
Your response must be concise. 0.63. What is the ratio of the Rent(as % of GDP) of Czech Republic in 2004 to that in 2008?
Provide a succinct answer. 0.88. What is the ratio of the Rent(as % of GDP) of Greece in 2004 to that in 2008?
Provide a short and direct response. 1.28. What is the ratio of the Rent(as % of GDP) in Japan in 2004 to that in 2008?
Offer a very short reply. 0.35. What is the ratio of the Rent(as % of GDP) in Europe(all income levels) in 2004 to that in 2009?
Your response must be concise. 1.48. What is the ratio of the Rent(as % of GDP) in Czech Republic in 2004 to that in 2009?
Keep it short and to the point. 1.63. What is the ratio of the Rent(as % of GDP) of Greece in 2004 to that in 2009?
Provide a succinct answer. 3.57. What is the ratio of the Rent(as % of GDP) of Japan in 2004 to that in 2009?
Offer a very short reply. 0.81. What is the ratio of the Rent(as % of GDP) of Europe(all income levels) in 2004 to that in 2010?
Offer a terse response. 1.59. What is the ratio of the Rent(as % of GDP) of Czech Republic in 2004 to that in 2010?
Your answer should be compact. 1.63. What is the ratio of the Rent(as % of GDP) of Greece in 2004 to that in 2010?
Your response must be concise. 5.5. What is the ratio of the Rent(as % of GDP) in Japan in 2004 to that in 2010?
Your answer should be compact. 1.01. What is the ratio of the Rent(as % of GDP) of Europe(all income levels) in 2004 to that in 2011?
Make the answer very short. 1.63. What is the ratio of the Rent(as % of GDP) in Czech Republic in 2004 to that in 2011?
Your answer should be compact. 1.76. What is the ratio of the Rent(as % of GDP) in Greece in 2004 to that in 2011?
Give a very brief answer. 5.78. What is the ratio of the Rent(as % of GDP) in Japan in 2004 to that in 2011?
Give a very brief answer. 0.97. What is the ratio of the Rent(as % of GDP) in Europe(all income levels) in 2005 to that in 2006?
Offer a very short reply. 1.06. What is the ratio of the Rent(as % of GDP) of Czech Republic in 2005 to that in 2006?
Provide a short and direct response. 1.24. What is the ratio of the Rent(as % of GDP) of Greece in 2005 to that in 2006?
Make the answer very short. 0.81. What is the ratio of the Rent(as % of GDP) of Japan in 2005 to that in 2006?
Offer a terse response. 0.89. What is the ratio of the Rent(as % of GDP) in Europe(all income levels) in 2005 to that in 2007?
Offer a terse response. 1.27. What is the ratio of the Rent(as % of GDP) in Czech Republic in 2005 to that in 2007?
Provide a short and direct response. 1.38. What is the ratio of the Rent(as % of GDP) in Greece in 2005 to that in 2007?
Offer a terse response. 1.12. What is the ratio of the Rent(as % of GDP) of Japan in 2005 to that in 2007?
Make the answer very short. 0.79. What is the ratio of the Rent(as % of GDP) of Europe(all income levels) in 2005 to that in 2008?
Your response must be concise. 0.9. What is the ratio of the Rent(as % of GDP) in Czech Republic in 2005 to that in 2008?
Your response must be concise. 1.18. What is the ratio of the Rent(as % of GDP) in Greece in 2005 to that in 2008?
Offer a terse response. 1.27. What is the ratio of the Rent(as % of GDP) in Japan in 2005 to that in 2008?
Your response must be concise. 0.61. What is the ratio of the Rent(as % of GDP) of Europe(all income levels) in 2005 to that in 2009?
Ensure brevity in your answer.  2.12. What is the ratio of the Rent(as % of GDP) of Czech Republic in 2005 to that in 2009?
Ensure brevity in your answer.  2.18. What is the ratio of the Rent(as % of GDP) of Greece in 2005 to that in 2009?
Provide a short and direct response. 3.53. What is the ratio of the Rent(as % of GDP) in Japan in 2005 to that in 2009?
Provide a short and direct response. 1.4. What is the ratio of the Rent(as % of GDP) of Europe(all income levels) in 2005 to that in 2010?
Provide a succinct answer. 2.28. What is the ratio of the Rent(as % of GDP) of Czech Republic in 2005 to that in 2010?
Provide a short and direct response. 2.18. What is the ratio of the Rent(as % of GDP) in Greece in 2005 to that in 2010?
Provide a succinct answer. 5.44. What is the ratio of the Rent(as % of GDP) of Japan in 2005 to that in 2010?
Your response must be concise. 1.73. What is the ratio of the Rent(as % of GDP) in Europe(all income levels) in 2005 to that in 2011?
Ensure brevity in your answer.  2.34. What is the ratio of the Rent(as % of GDP) of Czech Republic in 2005 to that in 2011?
Your response must be concise. 2.34. What is the ratio of the Rent(as % of GDP) in Greece in 2005 to that in 2011?
Provide a succinct answer. 5.72. What is the ratio of the Rent(as % of GDP) of Japan in 2005 to that in 2011?
Provide a succinct answer. 1.67. What is the ratio of the Rent(as % of GDP) of Europe(all income levels) in 2006 to that in 2007?
Offer a very short reply. 1.19. What is the ratio of the Rent(as % of GDP) of Czech Republic in 2006 to that in 2007?
Make the answer very short. 1.11. What is the ratio of the Rent(as % of GDP) in Greece in 2006 to that in 2007?
Ensure brevity in your answer.  1.39. What is the ratio of the Rent(as % of GDP) in Japan in 2006 to that in 2007?
Your answer should be compact. 0.89. What is the ratio of the Rent(as % of GDP) of Europe(all income levels) in 2006 to that in 2008?
Offer a very short reply. 0.85. What is the ratio of the Rent(as % of GDP) of Czech Republic in 2006 to that in 2008?
Make the answer very short. 0.95. What is the ratio of the Rent(as % of GDP) of Greece in 2006 to that in 2008?
Ensure brevity in your answer.  1.57. What is the ratio of the Rent(as % of GDP) in Japan in 2006 to that in 2008?
Offer a very short reply. 0.68. What is the ratio of the Rent(as % of GDP) of Europe(all income levels) in 2006 to that in 2009?
Make the answer very short. 1.99. What is the ratio of the Rent(as % of GDP) of Czech Republic in 2006 to that in 2009?
Offer a very short reply. 1.75. What is the ratio of the Rent(as % of GDP) of Greece in 2006 to that in 2009?
Offer a very short reply. 4.36. What is the ratio of the Rent(as % of GDP) in Japan in 2006 to that in 2009?
Your answer should be very brief. 1.57. What is the ratio of the Rent(as % of GDP) in Europe(all income levels) in 2006 to that in 2010?
Keep it short and to the point. 2.15. What is the ratio of the Rent(as % of GDP) of Czech Republic in 2006 to that in 2010?
Give a very brief answer. 1.75. What is the ratio of the Rent(as % of GDP) in Greece in 2006 to that in 2010?
Give a very brief answer. 6.72. What is the ratio of the Rent(as % of GDP) of Japan in 2006 to that in 2010?
Keep it short and to the point. 1.94. What is the ratio of the Rent(as % of GDP) of Europe(all income levels) in 2006 to that in 2011?
Keep it short and to the point. 2.2. What is the ratio of the Rent(as % of GDP) of Czech Republic in 2006 to that in 2011?
Ensure brevity in your answer.  1.88. What is the ratio of the Rent(as % of GDP) in Greece in 2006 to that in 2011?
Provide a short and direct response. 7.07. What is the ratio of the Rent(as % of GDP) of Japan in 2006 to that in 2011?
Your answer should be compact. 1.88. What is the ratio of the Rent(as % of GDP) of Europe(all income levels) in 2007 to that in 2008?
Keep it short and to the point. 0.71. What is the ratio of the Rent(as % of GDP) in Czech Republic in 2007 to that in 2008?
Provide a succinct answer. 0.86. What is the ratio of the Rent(as % of GDP) in Greece in 2007 to that in 2008?
Your response must be concise. 1.13. What is the ratio of the Rent(as % of GDP) in Japan in 2007 to that in 2008?
Ensure brevity in your answer.  0.76. What is the ratio of the Rent(as % of GDP) of Europe(all income levels) in 2007 to that in 2009?
Your response must be concise. 1.67. What is the ratio of the Rent(as % of GDP) in Czech Republic in 2007 to that in 2009?
Provide a succinct answer. 1.58. What is the ratio of the Rent(as % of GDP) in Greece in 2007 to that in 2009?
Ensure brevity in your answer.  3.14. What is the ratio of the Rent(as % of GDP) in Japan in 2007 to that in 2009?
Make the answer very short. 1.76. What is the ratio of the Rent(as % of GDP) in Europe(all income levels) in 2007 to that in 2010?
Offer a very short reply. 1.8. What is the ratio of the Rent(as % of GDP) in Czech Republic in 2007 to that in 2010?
Offer a terse response. 1.58. What is the ratio of the Rent(as % of GDP) of Greece in 2007 to that in 2010?
Your answer should be compact. 4.83. What is the ratio of the Rent(as % of GDP) of Japan in 2007 to that in 2010?
Your answer should be very brief. 2.18. What is the ratio of the Rent(as % of GDP) of Europe(all income levels) in 2007 to that in 2011?
Offer a terse response. 1.84. What is the ratio of the Rent(as % of GDP) in Czech Republic in 2007 to that in 2011?
Give a very brief answer. 1.7. What is the ratio of the Rent(as % of GDP) in Greece in 2007 to that in 2011?
Your answer should be very brief. 5.08. What is the ratio of the Rent(as % of GDP) in Japan in 2007 to that in 2011?
Your answer should be very brief. 2.11. What is the ratio of the Rent(as % of GDP) of Europe(all income levels) in 2008 to that in 2009?
Give a very brief answer. 2.34. What is the ratio of the Rent(as % of GDP) in Czech Republic in 2008 to that in 2009?
Provide a succinct answer. 1.85. What is the ratio of the Rent(as % of GDP) in Greece in 2008 to that in 2009?
Your response must be concise. 2.78. What is the ratio of the Rent(as % of GDP) of Japan in 2008 to that in 2009?
Give a very brief answer. 2.31. What is the ratio of the Rent(as % of GDP) in Europe(all income levels) in 2008 to that in 2010?
Offer a terse response. 2.53. What is the ratio of the Rent(as % of GDP) in Czech Republic in 2008 to that in 2010?
Your answer should be very brief. 1.84. What is the ratio of the Rent(as % of GDP) in Greece in 2008 to that in 2010?
Make the answer very short. 4.28. What is the ratio of the Rent(as % of GDP) in Japan in 2008 to that in 2010?
Provide a short and direct response. 2.85. What is the ratio of the Rent(as % of GDP) in Europe(all income levels) in 2008 to that in 2011?
Your response must be concise. 2.59. What is the ratio of the Rent(as % of GDP) of Czech Republic in 2008 to that in 2011?
Keep it short and to the point. 1.99. What is the ratio of the Rent(as % of GDP) in Greece in 2008 to that in 2011?
Ensure brevity in your answer.  4.5. What is the ratio of the Rent(as % of GDP) of Japan in 2008 to that in 2011?
Provide a succinct answer. 2.77. What is the ratio of the Rent(as % of GDP) of Europe(all income levels) in 2009 to that in 2010?
Your answer should be compact. 1.08. What is the ratio of the Rent(as % of GDP) in Czech Republic in 2009 to that in 2010?
Give a very brief answer. 1. What is the ratio of the Rent(as % of GDP) in Greece in 2009 to that in 2010?
Keep it short and to the point. 1.54. What is the ratio of the Rent(as % of GDP) in Japan in 2009 to that in 2010?
Keep it short and to the point. 1.23. What is the ratio of the Rent(as % of GDP) in Europe(all income levels) in 2009 to that in 2011?
Ensure brevity in your answer.  1.11. What is the ratio of the Rent(as % of GDP) of Czech Republic in 2009 to that in 2011?
Your answer should be very brief. 1.08. What is the ratio of the Rent(as % of GDP) in Greece in 2009 to that in 2011?
Provide a succinct answer. 1.62. What is the ratio of the Rent(as % of GDP) in Japan in 2009 to that in 2011?
Make the answer very short. 1.2. What is the ratio of the Rent(as % of GDP) of Europe(all income levels) in 2010 to that in 2011?
Offer a terse response. 1.02. What is the ratio of the Rent(as % of GDP) in Czech Republic in 2010 to that in 2011?
Offer a very short reply. 1.08. What is the ratio of the Rent(as % of GDP) in Greece in 2010 to that in 2011?
Your answer should be very brief. 1.05. What is the ratio of the Rent(as % of GDP) of Japan in 2010 to that in 2011?
Give a very brief answer. 0.97. What is the difference between the highest and the second highest Rent(as % of GDP) of Europe(all income levels)?
Offer a very short reply. 0.13. What is the difference between the highest and the second highest Rent(as % of GDP) in Czech Republic?
Ensure brevity in your answer.  0. What is the difference between the highest and the second highest Rent(as % of GDP) of Japan?
Your response must be concise. 0.01. What is the difference between the highest and the lowest Rent(as % of GDP) in Europe(all income levels)?
Make the answer very short. 0.82. What is the difference between the highest and the lowest Rent(as % of GDP) of Czech Republic?
Your response must be concise. 0.02. What is the difference between the highest and the lowest Rent(as % of GDP) of Greece?
Offer a terse response. 0. What is the difference between the highest and the lowest Rent(as % of GDP) of Japan?
Provide a short and direct response. 0.02. 